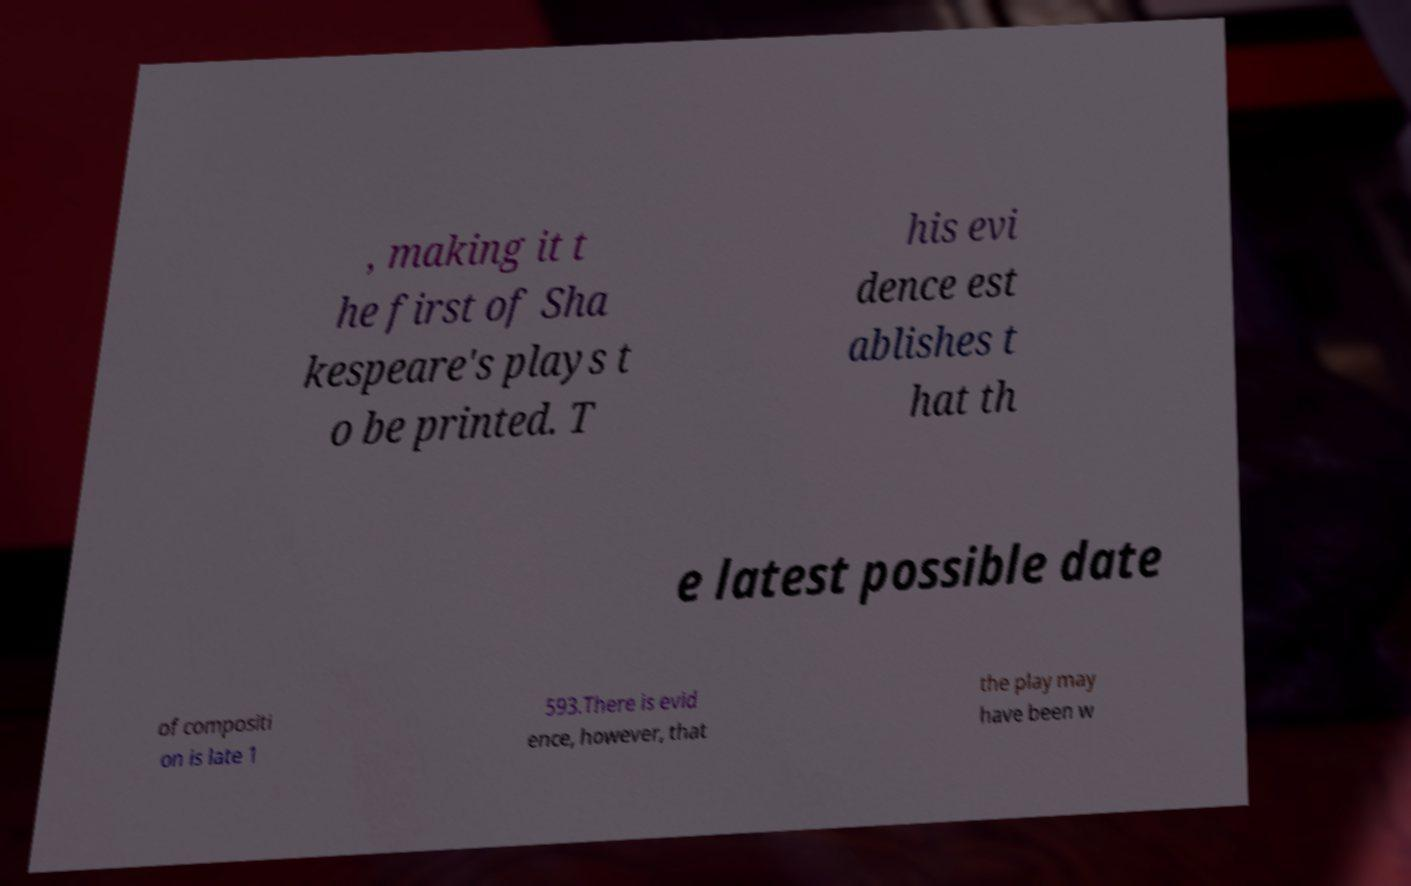Could you assist in decoding the text presented in this image and type it out clearly? , making it t he first of Sha kespeare's plays t o be printed. T his evi dence est ablishes t hat th e latest possible date of compositi on is late 1 593.There is evid ence, however, that the play may have been w 